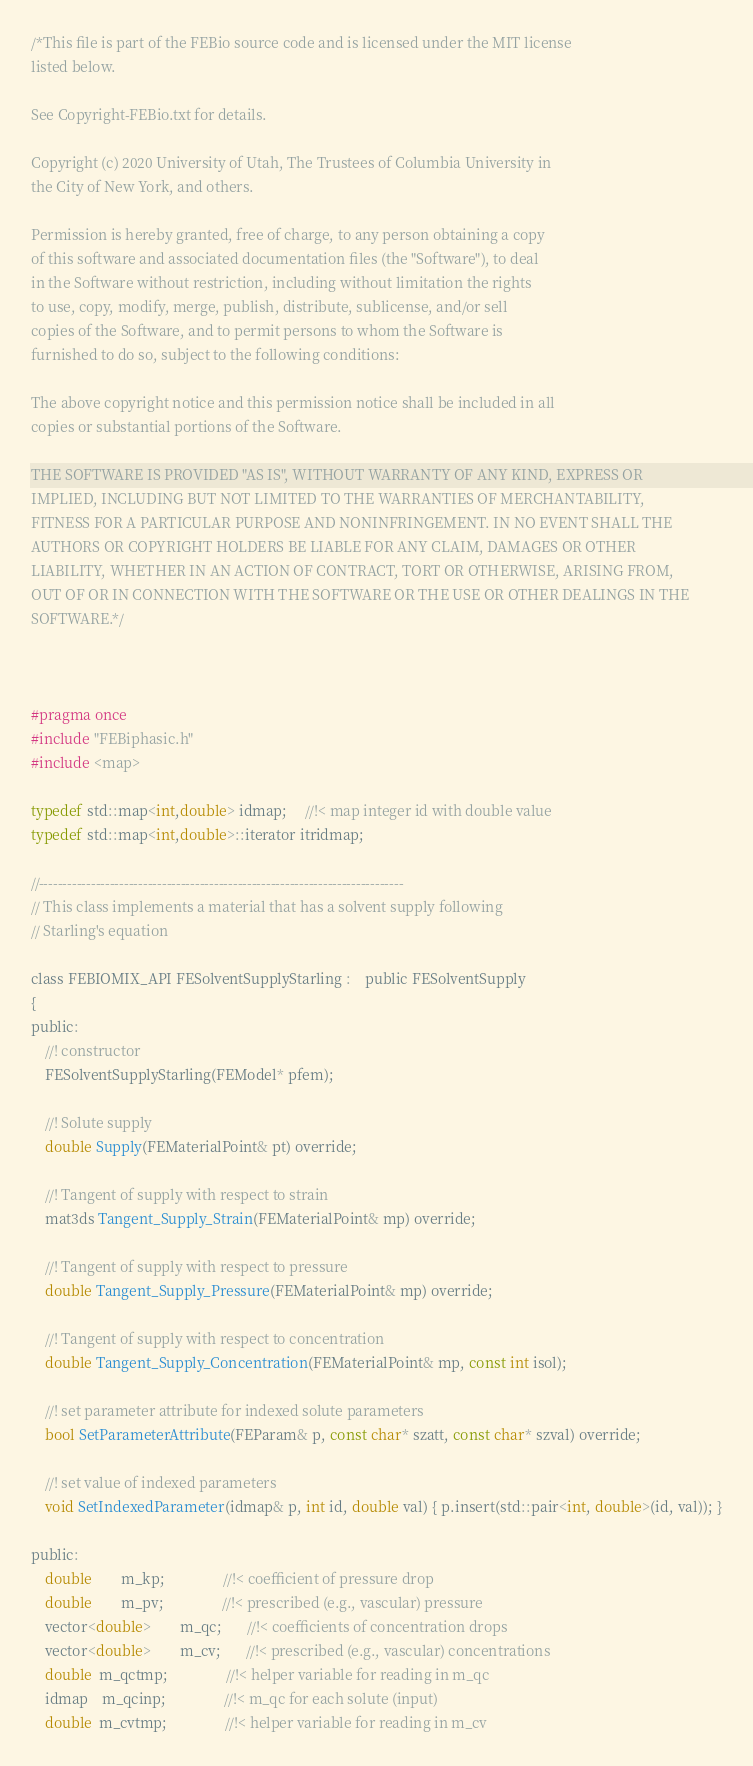Convert code to text. <code><loc_0><loc_0><loc_500><loc_500><_C_>/*This file is part of the FEBio source code and is licensed under the MIT license
listed below.

See Copyright-FEBio.txt for details.

Copyright (c) 2020 University of Utah, The Trustees of Columbia University in 
the City of New York, and others.

Permission is hereby granted, free of charge, to any person obtaining a copy
of this software and associated documentation files (the "Software"), to deal
in the Software without restriction, including without limitation the rights
to use, copy, modify, merge, publish, distribute, sublicense, and/or sell
copies of the Software, and to permit persons to whom the Software is
furnished to do so, subject to the following conditions:

The above copyright notice and this permission notice shall be included in all
copies or substantial portions of the Software.

THE SOFTWARE IS PROVIDED "AS IS", WITHOUT WARRANTY OF ANY KIND, EXPRESS OR
IMPLIED, INCLUDING BUT NOT LIMITED TO THE WARRANTIES OF MERCHANTABILITY,
FITNESS FOR A PARTICULAR PURPOSE AND NONINFRINGEMENT. IN NO EVENT SHALL THE
AUTHORS OR COPYRIGHT HOLDERS BE LIABLE FOR ANY CLAIM, DAMAGES OR OTHER
LIABILITY, WHETHER IN AN ACTION OF CONTRACT, TORT OR OTHERWISE, ARISING FROM,
OUT OF OR IN CONNECTION WITH THE SOFTWARE OR THE USE OR OTHER DEALINGS IN THE
SOFTWARE.*/



#pragma once
#include "FEBiphasic.h"
#include <map>

typedef std::map<int,double> idmap;     //!< map integer id with double value
typedef std::map<int,double>::iterator itridmap;

//-----------------------------------------------------------------------------
// This class implements a material that has a solvent supply following
// Starling's equation

class FEBIOMIX_API FESolventSupplyStarling :	public FESolventSupply
{
public:
	//! constructor
	FESolventSupplyStarling(FEModel* pfem);
	
	//! Solute supply
	double Supply(FEMaterialPoint& pt) override;
	
	//! Tangent of supply with respect to strain
	mat3ds Tangent_Supply_Strain(FEMaterialPoint& mp) override;
	
	//! Tangent of supply with respect to pressure
	double Tangent_Supply_Pressure(FEMaterialPoint& mp) override;
	
	//! Tangent of supply with respect to concentration
	double Tangent_Supply_Concentration(FEMaterialPoint& mp, const int isol);
	
    //! set parameter attribute for indexed solute parameters
	bool SetParameterAttribute(FEParam& p, const char* szatt, const char* szval) override;
    
	//! set value of indexed parameters
	void SetIndexedParameter(idmap& p, int id, double val) { p.insert(std::pair<int, double>(id, val)); }
    
public:
	double		m_kp;				//!< coefficient of pressure drop
	double		m_pv;				//!< prescribed (e.g., vascular) pressure
	vector<double>		m_qc;       //!< coefficients of concentration drops
	vector<double>		m_cv;       //!< prescribed (e.g., vascular) concentrations
    double  m_qctmp;                //!< helper variable for reading in m_qc
    idmap	m_qcinp;                //!< m_qc for each solute (input)
    double  m_cvtmp;                //!< helper variable for reading in m_cv</code> 